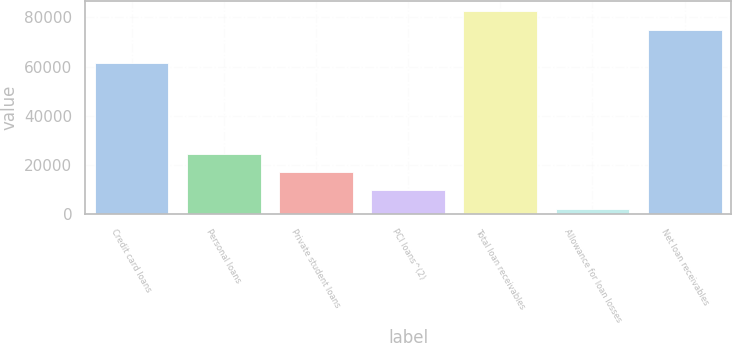Convert chart to OTSL. <chart><loc_0><loc_0><loc_500><loc_500><bar_chart><fcel>Credit card loans<fcel>Personal loans<fcel>Private student loans<fcel>PCI loans^(2)<fcel>Total loan receivables<fcel>Allowance for loan losses<fcel>Net loan receivables<nl><fcel>61522<fcel>24693.1<fcel>17184.4<fcel>9675.7<fcel>82595.7<fcel>2167<fcel>75087<nl></chart> 